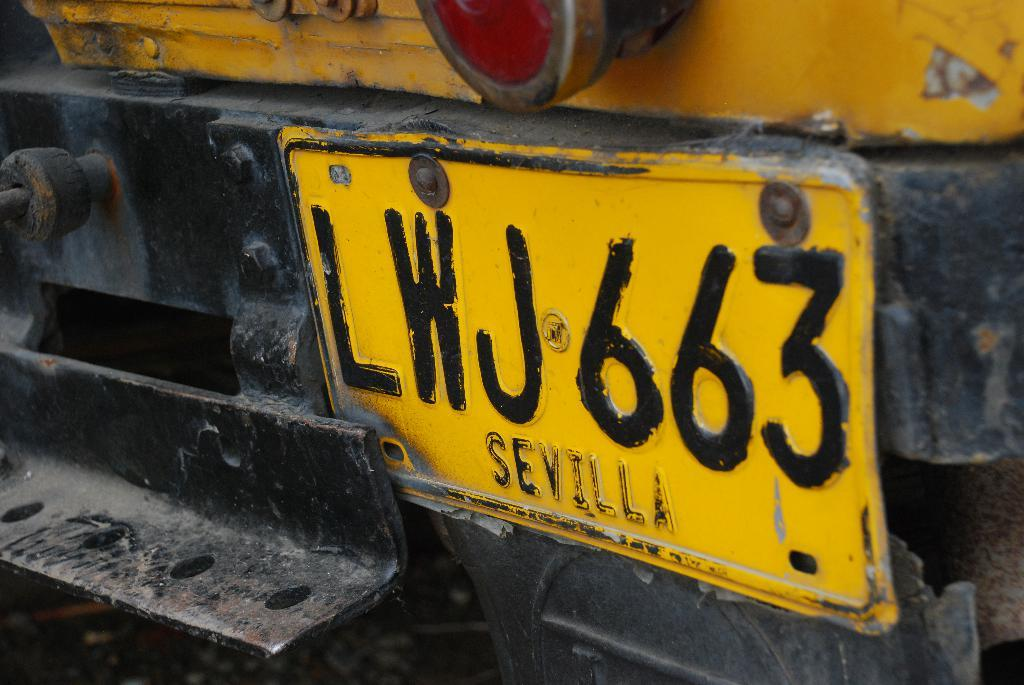<image>
Summarize the visual content of the image. Yellow license plate which says LWJ663 o nit. 